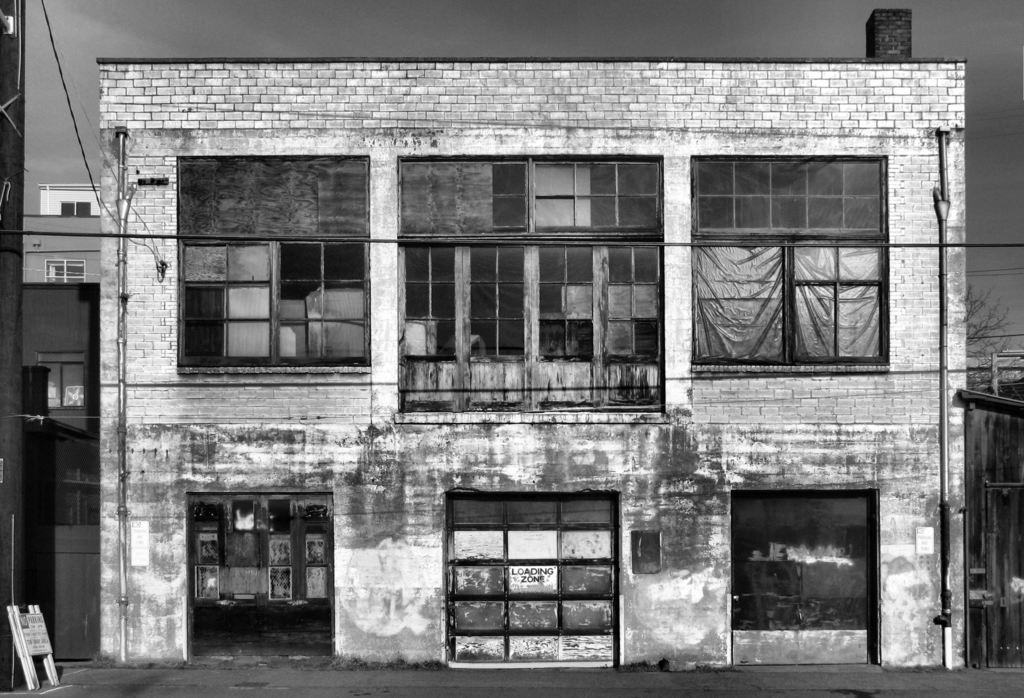What is the color scheme of the image? The image is black and white. What is the main subject of the image? There is a building in the image. What features can be seen on the building? The building has doors, windows, pipes, and a brick wall. What is visible in the background of the image? There is sky, other buildings, and a tree visible in the background of the image. What type of glass is used in the windows of the building? The image is black and white, so it is not possible to determine the type of glass used in the windows of the building. How does the building make you feel when looking at the image? The image is a description of the visual elements in the picture, and feelings are subjective experiences that cannot be definitively determined from the image. 